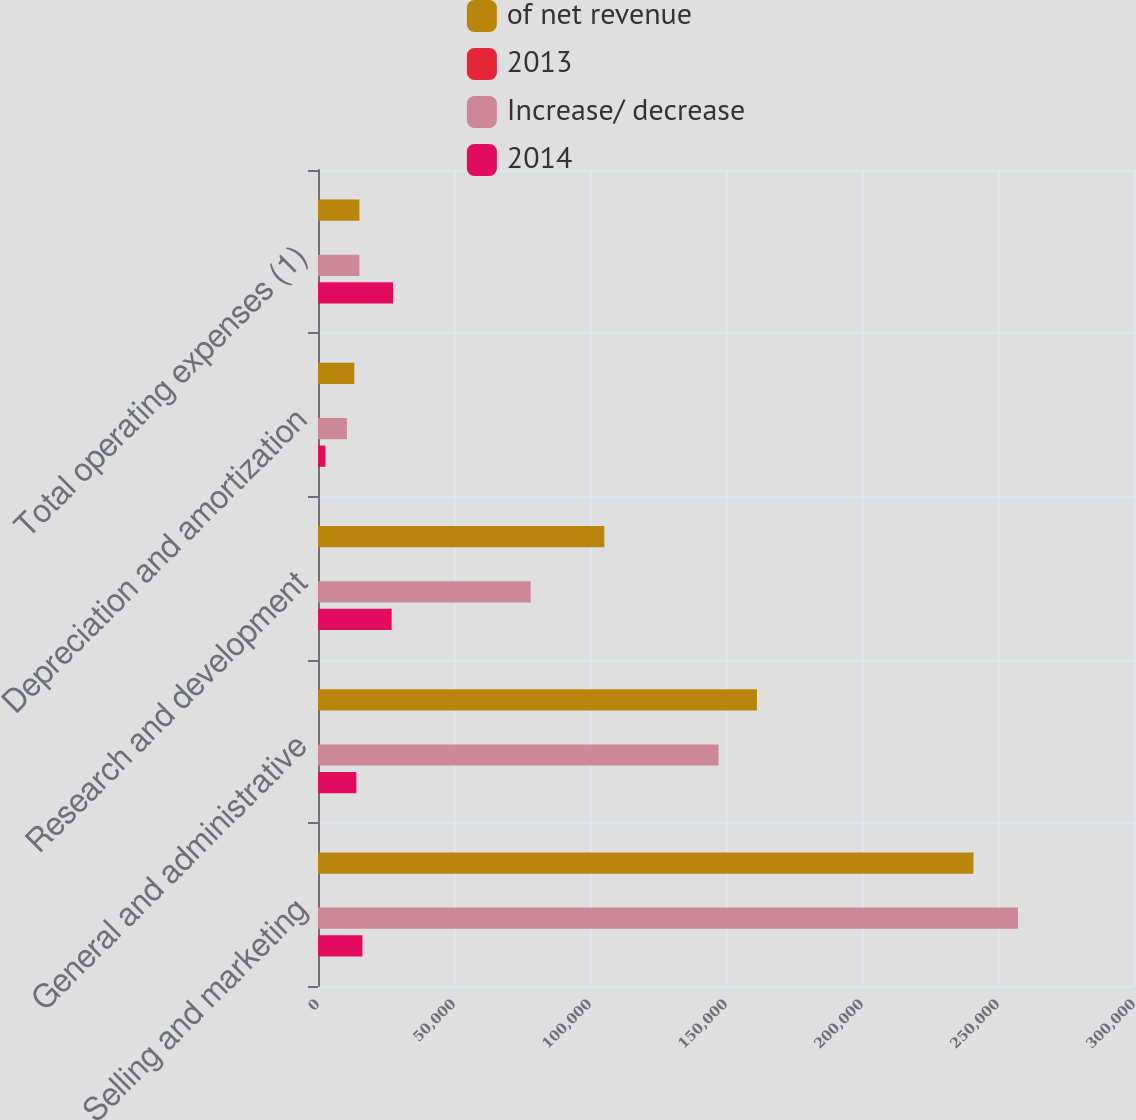<chart> <loc_0><loc_0><loc_500><loc_500><stacked_bar_chart><ecel><fcel>Selling and marketing<fcel>General and administrative<fcel>Research and development<fcel>Depreciation and amortization<fcel>Total operating expenses (1)<nl><fcel>of net revenue<fcel>240996<fcel>161374<fcel>105256<fcel>13359<fcel>15223.5<nl><fcel>2013<fcel>10.2<fcel>6.9<fcel>4.5<fcel>0.6<fcel>22.2<nl><fcel>Increase/ decrease<fcel>257329<fcel>147260<fcel>78184<fcel>10634<fcel>15223.5<nl><fcel>2014<fcel>16333<fcel>14114<fcel>27072<fcel>2725<fcel>27578<nl></chart> 